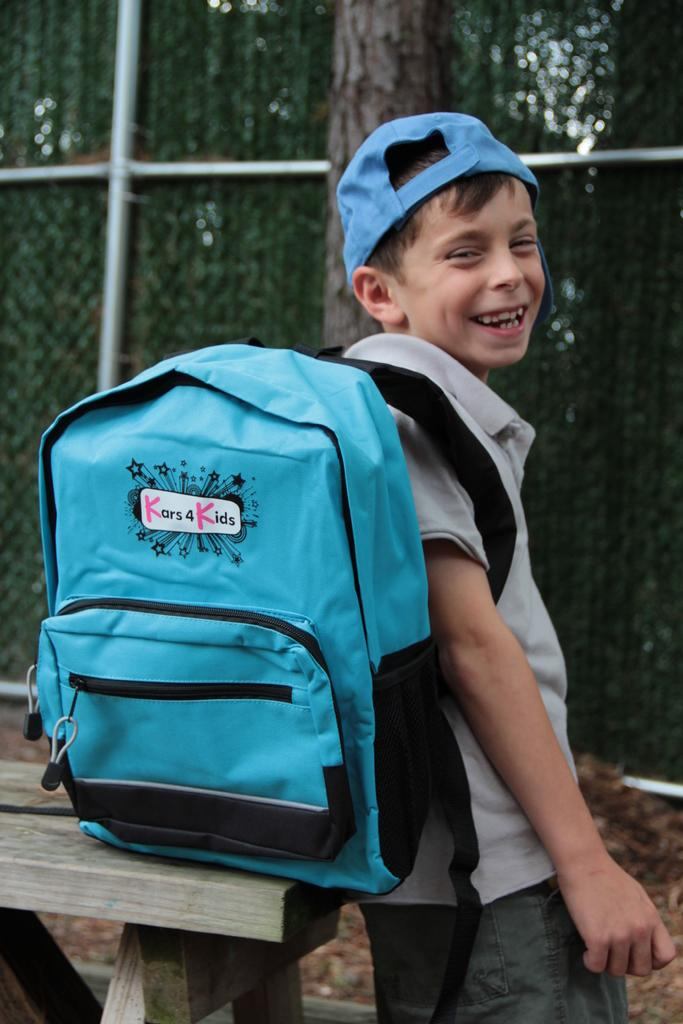Who is the main subject in the image? There is a boy in the image. What is the boy carrying in the image? The boy is carrying a backpack. What is the boy's facial expression in the image? The boy is smiling. What can be seen in the background of the image? There is a fence in the background of the image. Does the boy have wings in the image? No, the boy does not have wings in the image. How many knots are tied on the fence in the image? There is no mention of knots on the fence in the image, so we cannot determine the number of knots. 